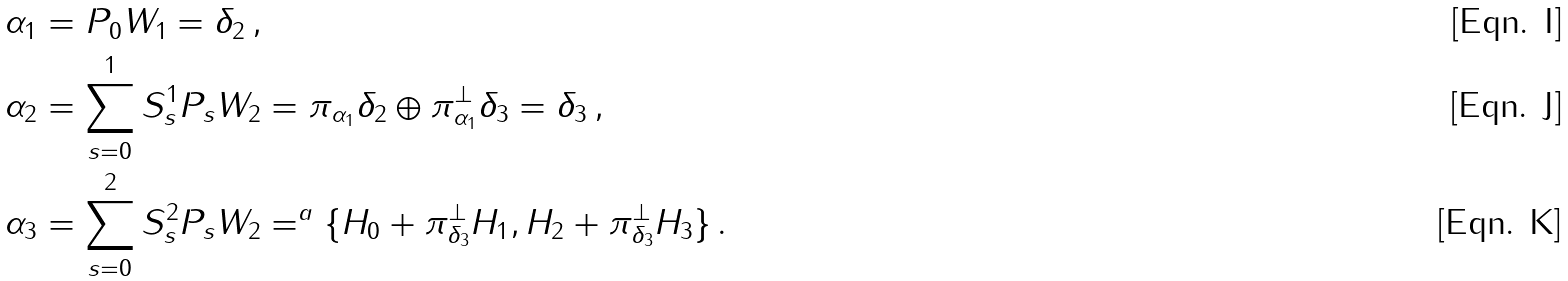Convert formula to latex. <formula><loc_0><loc_0><loc_500><loc_500>\alpha _ { 1 } & = P _ { 0 } W _ { 1 } = \delta _ { 2 } \, , \\ \alpha _ { 2 } & = \sum _ { s = 0 } ^ { 1 } S ^ { 1 } _ { s } P _ { s } W _ { 2 } = \pi _ { \alpha _ { 1 } } \delta _ { 2 } \oplus \pi _ { \alpha _ { 1 } } ^ { \perp } \delta _ { 3 } = \delta _ { 3 } \, , \\ \alpha _ { 3 } & = \sum _ { s = 0 } ^ { 2 } S ^ { 2 } _ { s } P _ { s } W _ { 2 } = ^ { a } \{ H _ { 0 } + \pi _ { \delta _ { 3 } } ^ { \perp } H _ { 1 } , H _ { 2 } + \pi _ { \delta _ { 3 } } ^ { \perp } H _ { 3 } \} \, .</formula> 